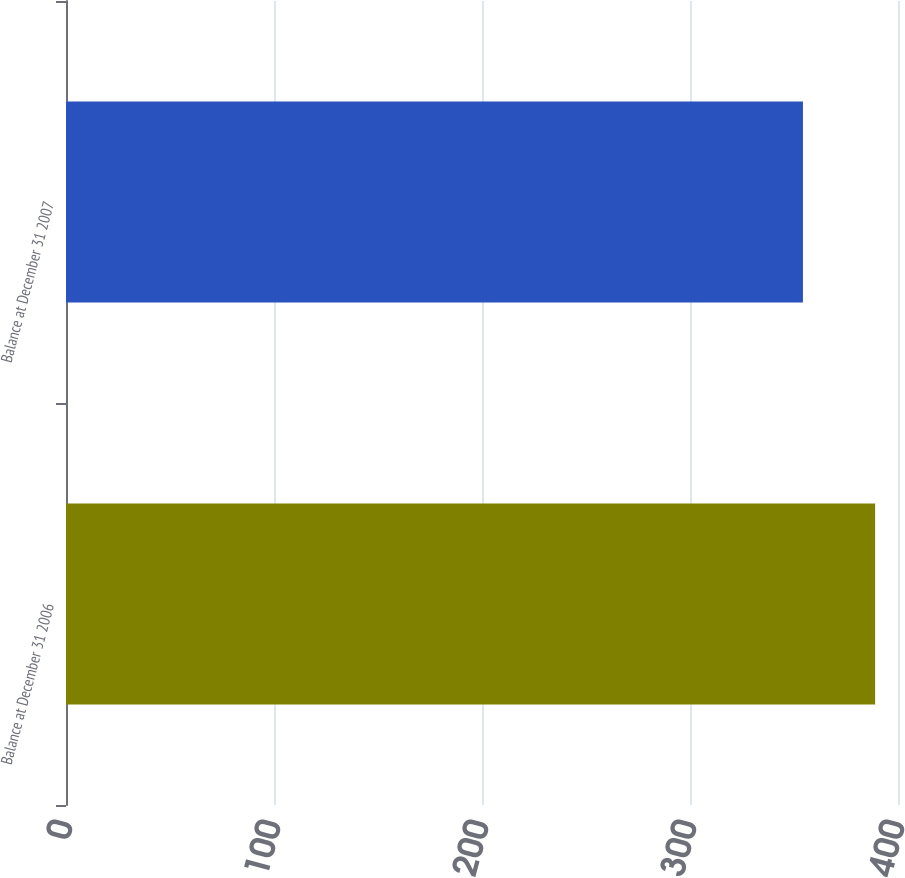Convert chart. <chart><loc_0><loc_0><loc_500><loc_500><bar_chart><fcel>Balance at December 31 2006<fcel>Balance at December 31 2007<nl><fcel>389<fcel>354.3<nl></chart> 